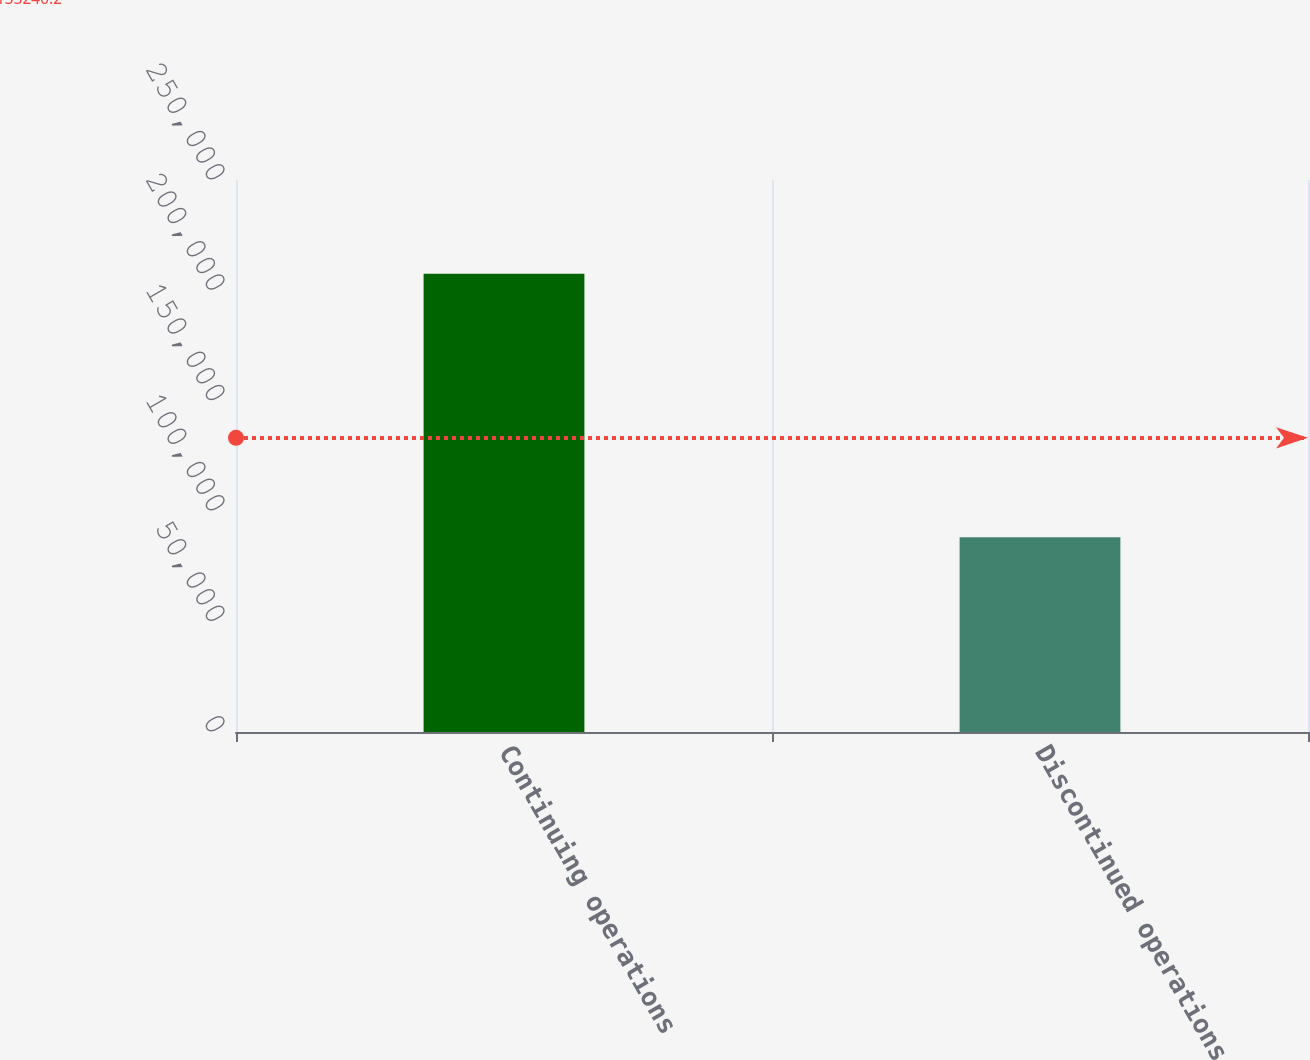<chart> <loc_0><loc_0><loc_500><loc_500><bar_chart><fcel>Continuing operations<fcel>Discontinued operations<nl><fcel>207510<fcel>88216<nl></chart> 